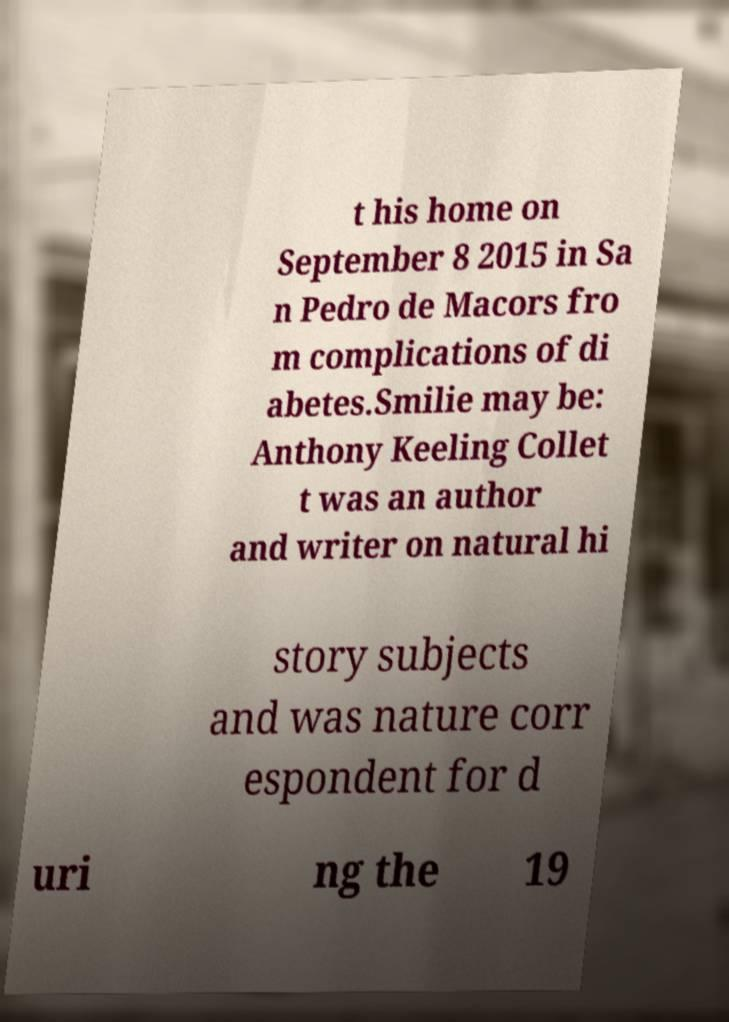Please read and relay the text visible in this image. What does it say? t his home on September 8 2015 in Sa n Pedro de Macors fro m complications of di abetes.Smilie may be: Anthony Keeling Collet t was an author and writer on natural hi story subjects and was nature corr espondent for d uri ng the 19 